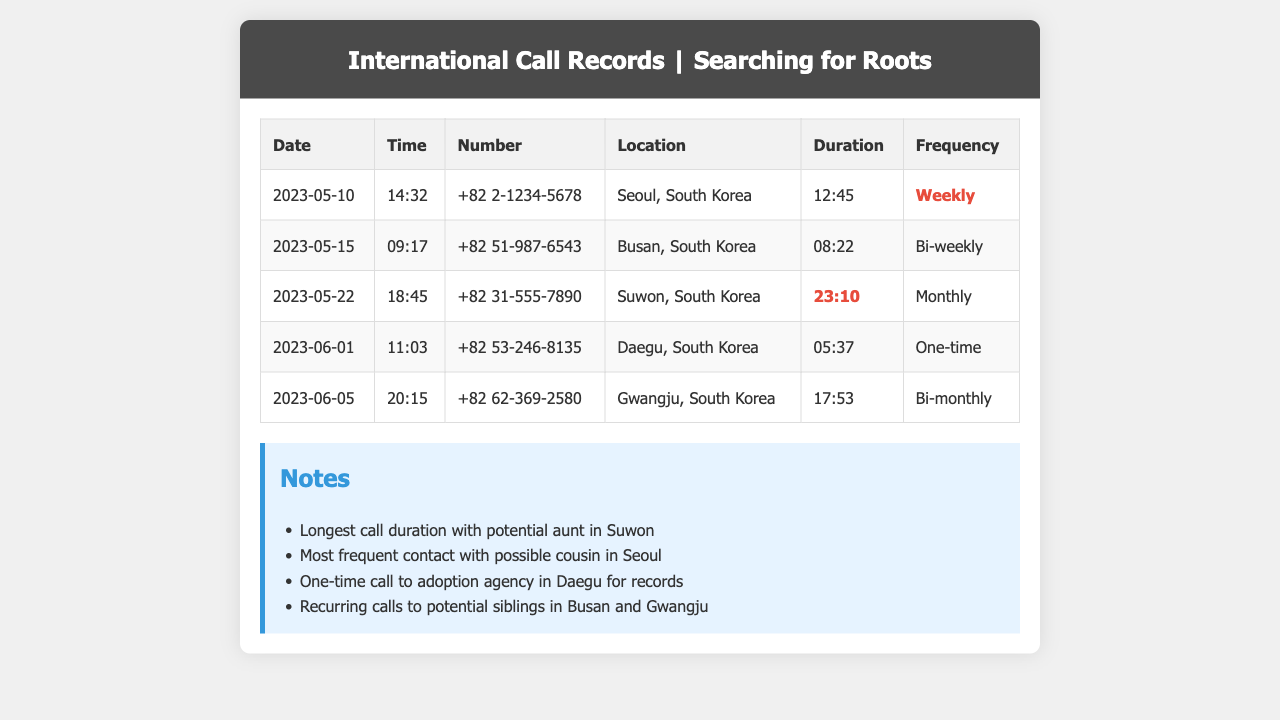What is the date of the longest call? The longest call was made on May 22, 2023, to a potential aunt in Suwon, which lasted 23 minutes and 10 seconds.
Answer: May 22, 2023 How long was the call to the adoption agency? The one-time call to the adoption agency in Daegu lasted for 5 minutes and 37 seconds.
Answer: 5:37 Which city had the most frequent contact? The most frequent contact listed in the records is with a possible cousin in Seoul, noted as weekly frequency.
Answer: Seoul What is the location of the call made on June 5? The call recorded on June 5, 2023, took place in Gwangju, South Korea.
Answer: Gwangju, South Korea How many calls are listed as bi-monthly? There is one call listed with a bi-monthly frequency, which is on June 5, 2023, to Gwangju.
Answer: One What was the duration of the call made on May 10? The call made on May 10, 2023, to Seoul lasted 12 minutes and 45 seconds.
Answer: 12:45 What is the frequency of the call made to Busan? The call made on May 15, 2023, to Busan has a bi-weekly frequency.
Answer: Bi-weekly What type of notes are provided in the document? The notes highlight specific details about call durations and relationships, such as the longest call and recurring contacts.
Answer: Specific details about calls 